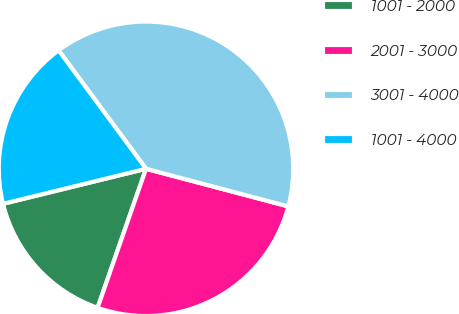<chart> <loc_0><loc_0><loc_500><loc_500><pie_chart><fcel>1001 - 2000<fcel>2001 - 3000<fcel>3001 - 4000<fcel>1001 - 4000<nl><fcel>15.84%<fcel>26.22%<fcel>39.23%<fcel>18.71%<nl></chart> 